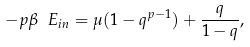<formula> <loc_0><loc_0><loc_500><loc_500>- p \beta \ E _ { i n } = \mu ( 1 - q ^ { p - 1 } ) + { \frac { q } { 1 - q } } ,</formula> 